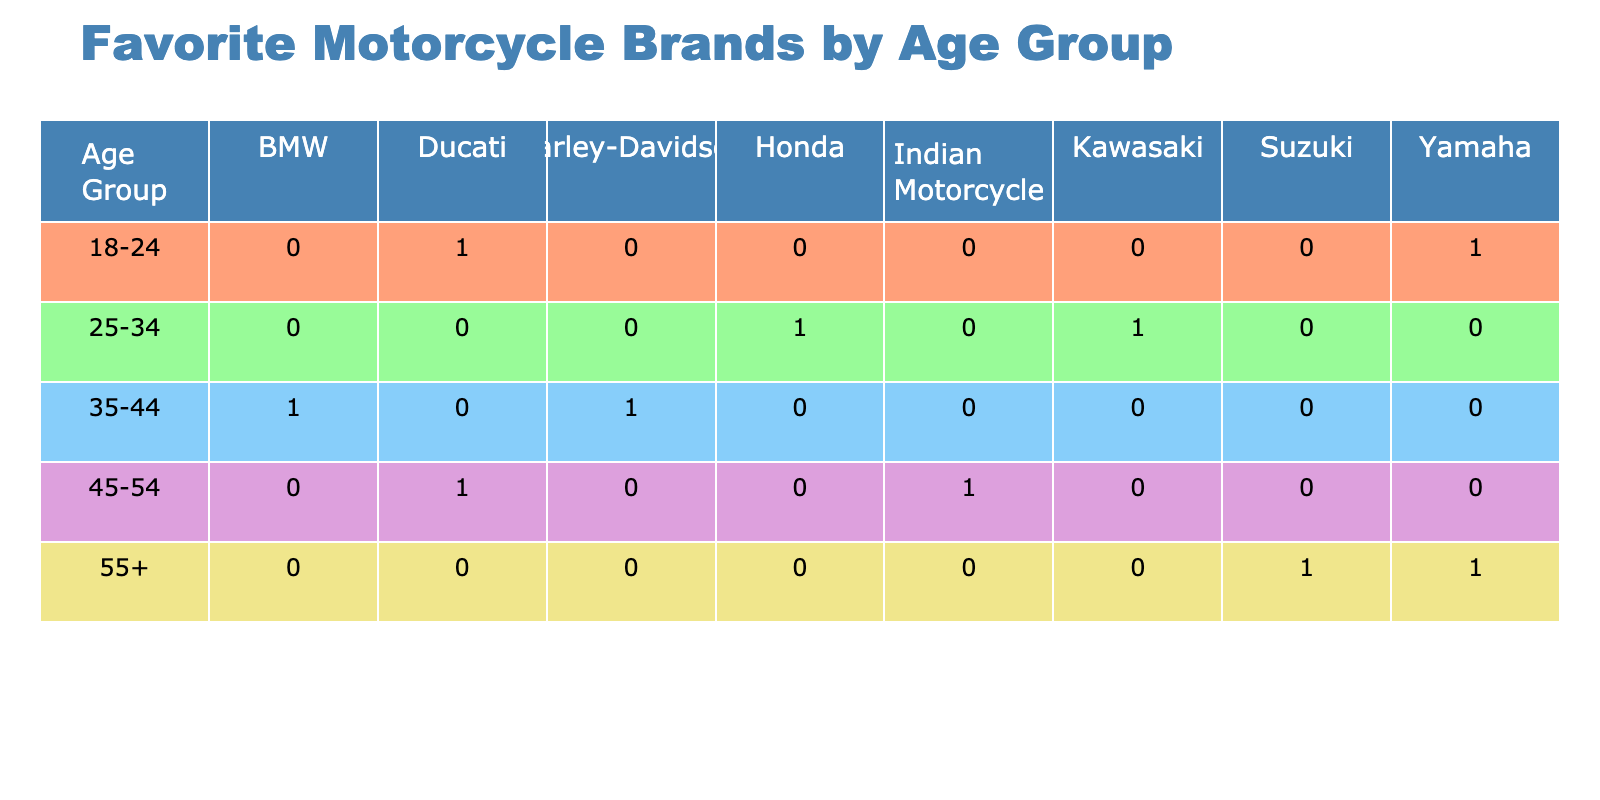What is the favorite motorcycle brand of the 18-24 age group? Looking at the table, under the 18-24 age group, there are two entries: one male who prefers Ducati and one female who prefers Yamaha. Thus, both Ducati and Yamaha are popular among the 18-24 age group.
Answer: Ducati, Yamaha Which age group has the highest preference for Harley-Davidson? The table shows that only the 35-44 age group has a preference for Harley-Davidson (female from Berlin). Therefore, this age group is the only one with this preference.
Answer: 35-44 How many males prefer Honda as their motorcycle brand? In the table, there is a single entry for the age group 25-34 where a male prefers Honda. Therefore, there is one male who prefers Honda.
Answer: 1 Are there any females who prefer Ducati? Checking the table, a female from Paris, aged 45-54, lists Ducati as her favorite brand. Hence, there is indeed a female who prefers Ducati.
Answer: Yes What is the total count of riders who prefer Suzuki and are aged 55 and above? The table has one entry for the 55+ age group where a male from San Francisco prefers Suzuki. Hence, the total count is 1.
Answer: 1 Which motorcycle brand is the most popular among males aged 45-54? In the age group 45-54, the table shows two entries. One male prefers Indian Motorcycle and another male prefers Ducati. We need to determine which brand has more preference. As both are different, no brand is more popular, making them equally favored.
Answer: Indian Motorcycle, Ducati What is the difference in the number of riders who prefer Yamaha and those who prefer BMW? The data shows one female prefers Yamaha in the 18-24 age group and one male prefers Yamaha in the 55+ age group, making a total of 2 for Yamaha. BMW is only preferred by one male in the 35-44 age group. The difference is 2 - 1 = 1.
Answer: 1 Which age group has the highest number of motorcycle preferences and what is that number? By examining the table, each age group has a unique preference distribution: 18-24 has 2 (Ducati, Yamaha), 25-34 has 2 (Honda, Kawasaki), 35-44 has 2 (BMW, Harley-Davidson), 45-54 has 2 (Indian Motorcycle, Ducati), and 55+ has 2 (Suzuki, Yamaha). Since all groups have the same count of 2, no age group is distinctly higher.
Answer: 2 What is the favorite motorcycle brand among female riders in the 35-44 age group? According to the table, there is a single entry for the 35-44 age group where a female prefers Harley-Davidson. Hence, Harley-Davidson is the favorite for females in this group.
Answer: Harley-Davidson 